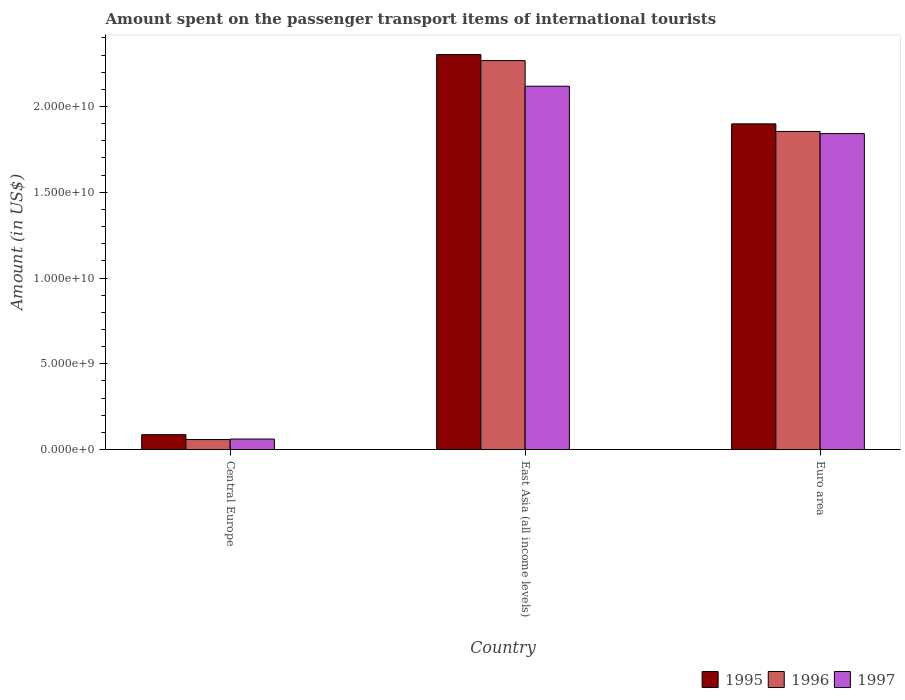How many groups of bars are there?
Ensure brevity in your answer.  3. Are the number of bars per tick equal to the number of legend labels?
Provide a short and direct response. Yes. Are the number of bars on each tick of the X-axis equal?
Keep it short and to the point. Yes. How many bars are there on the 3rd tick from the left?
Provide a short and direct response. 3. What is the label of the 2nd group of bars from the left?
Your response must be concise. East Asia (all income levels). In how many cases, is the number of bars for a given country not equal to the number of legend labels?
Give a very brief answer. 0. What is the amount spent on the passenger transport items of international tourists in 1997 in Euro area?
Provide a short and direct response. 1.84e+1. Across all countries, what is the maximum amount spent on the passenger transport items of international tourists in 1997?
Keep it short and to the point. 2.12e+1. Across all countries, what is the minimum amount spent on the passenger transport items of international tourists in 1997?
Your answer should be compact. 6.10e+08. In which country was the amount spent on the passenger transport items of international tourists in 1997 maximum?
Provide a succinct answer. East Asia (all income levels). In which country was the amount spent on the passenger transport items of international tourists in 1996 minimum?
Ensure brevity in your answer.  Central Europe. What is the total amount spent on the passenger transport items of international tourists in 1997 in the graph?
Your answer should be very brief. 4.02e+1. What is the difference between the amount spent on the passenger transport items of international tourists in 1997 in East Asia (all income levels) and that in Euro area?
Make the answer very short. 2.76e+09. What is the difference between the amount spent on the passenger transport items of international tourists in 1995 in East Asia (all income levels) and the amount spent on the passenger transport items of international tourists in 1996 in Central Europe?
Your response must be concise. 2.24e+1. What is the average amount spent on the passenger transport items of international tourists in 1995 per country?
Your answer should be very brief. 1.43e+1. What is the difference between the amount spent on the passenger transport items of international tourists of/in 1995 and amount spent on the passenger transport items of international tourists of/in 1996 in East Asia (all income levels)?
Keep it short and to the point. 3.50e+08. What is the ratio of the amount spent on the passenger transport items of international tourists in 1996 in Central Europe to that in Euro area?
Offer a very short reply. 0.03. Is the amount spent on the passenger transport items of international tourists in 1995 in Central Europe less than that in Euro area?
Your answer should be very brief. Yes. Is the difference between the amount spent on the passenger transport items of international tourists in 1995 in Central Europe and East Asia (all income levels) greater than the difference between the amount spent on the passenger transport items of international tourists in 1996 in Central Europe and East Asia (all income levels)?
Provide a succinct answer. No. What is the difference between the highest and the second highest amount spent on the passenger transport items of international tourists in 1995?
Provide a succinct answer. -2.22e+1. What is the difference between the highest and the lowest amount spent on the passenger transport items of international tourists in 1996?
Make the answer very short. 2.21e+1. Is the sum of the amount spent on the passenger transport items of international tourists in 1996 in Central Europe and East Asia (all income levels) greater than the maximum amount spent on the passenger transport items of international tourists in 1997 across all countries?
Provide a succinct answer. Yes. How many bars are there?
Your response must be concise. 9. How many countries are there in the graph?
Give a very brief answer. 3. What is the difference between two consecutive major ticks on the Y-axis?
Provide a succinct answer. 5.00e+09. Does the graph contain any zero values?
Give a very brief answer. No. Does the graph contain grids?
Offer a terse response. No. Where does the legend appear in the graph?
Your answer should be compact. Bottom right. What is the title of the graph?
Make the answer very short. Amount spent on the passenger transport items of international tourists. What is the label or title of the X-axis?
Ensure brevity in your answer.  Country. What is the Amount (in US$) in 1995 in Central Europe?
Your answer should be compact. 8.65e+08. What is the Amount (in US$) in 1996 in Central Europe?
Provide a succinct answer. 5.81e+08. What is the Amount (in US$) of 1997 in Central Europe?
Ensure brevity in your answer.  6.10e+08. What is the Amount (in US$) of 1995 in East Asia (all income levels)?
Offer a terse response. 2.30e+1. What is the Amount (in US$) of 1996 in East Asia (all income levels)?
Ensure brevity in your answer.  2.27e+1. What is the Amount (in US$) in 1997 in East Asia (all income levels)?
Ensure brevity in your answer.  2.12e+1. What is the Amount (in US$) in 1995 in Euro area?
Give a very brief answer. 1.90e+1. What is the Amount (in US$) in 1996 in Euro area?
Offer a very short reply. 1.85e+1. What is the Amount (in US$) of 1997 in Euro area?
Offer a very short reply. 1.84e+1. Across all countries, what is the maximum Amount (in US$) in 1995?
Ensure brevity in your answer.  2.30e+1. Across all countries, what is the maximum Amount (in US$) of 1996?
Your response must be concise. 2.27e+1. Across all countries, what is the maximum Amount (in US$) in 1997?
Provide a short and direct response. 2.12e+1. Across all countries, what is the minimum Amount (in US$) in 1995?
Offer a very short reply. 8.65e+08. Across all countries, what is the minimum Amount (in US$) in 1996?
Offer a terse response. 5.81e+08. Across all countries, what is the minimum Amount (in US$) of 1997?
Your answer should be compact. 6.10e+08. What is the total Amount (in US$) of 1995 in the graph?
Offer a very short reply. 4.29e+1. What is the total Amount (in US$) of 1996 in the graph?
Your answer should be compact. 4.18e+1. What is the total Amount (in US$) in 1997 in the graph?
Your response must be concise. 4.02e+1. What is the difference between the Amount (in US$) in 1995 in Central Europe and that in East Asia (all income levels)?
Make the answer very short. -2.22e+1. What is the difference between the Amount (in US$) in 1996 in Central Europe and that in East Asia (all income levels)?
Your answer should be compact. -2.21e+1. What is the difference between the Amount (in US$) of 1997 in Central Europe and that in East Asia (all income levels)?
Make the answer very short. -2.06e+1. What is the difference between the Amount (in US$) in 1995 in Central Europe and that in Euro area?
Your answer should be compact. -1.81e+1. What is the difference between the Amount (in US$) of 1996 in Central Europe and that in Euro area?
Provide a short and direct response. -1.80e+1. What is the difference between the Amount (in US$) in 1997 in Central Europe and that in Euro area?
Provide a short and direct response. -1.78e+1. What is the difference between the Amount (in US$) in 1995 in East Asia (all income levels) and that in Euro area?
Keep it short and to the point. 4.04e+09. What is the difference between the Amount (in US$) in 1996 in East Asia (all income levels) and that in Euro area?
Provide a succinct answer. 4.13e+09. What is the difference between the Amount (in US$) of 1997 in East Asia (all income levels) and that in Euro area?
Keep it short and to the point. 2.76e+09. What is the difference between the Amount (in US$) in 1995 in Central Europe and the Amount (in US$) in 1996 in East Asia (all income levels)?
Your answer should be compact. -2.18e+1. What is the difference between the Amount (in US$) of 1995 in Central Europe and the Amount (in US$) of 1997 in East Asia (all income levels)?
Give a very brief answer. -2.03e+1. What is the difference between the Amount (in US$) of 1996 in Central Europe and the Amount (in US$) of 1997 in East Asia (all income levels)?
Offer a very short reply. -2.06e+1. What is the difference between the Amount (in US$) of 1995 in Central Europe and the Amount (in US$) of 1996 in Euro area?
Your answer should be very brief. -1.77e+1. What is the difference between the Amount (in US$) of 1995 in Central Europe and the Amount (in US$) of 1997 in Euro area?
Give a very brief answer. -1.76e+1. What is the difference between the Amount (in US$) of 1996 in Central Europe and the Amount (in US$) of 1997 in Euro area?
Offer a very short reply. -1.78e+1. What is the difference between the Amount (in US$) in 1995 in East Asia (all income levels) and the Amount (in US$) in 1996 in Euro area?
Make the answer very short. 4.48e+09. What is the difference between the Amount (in US$) in 1995 in East Asia (all income levels) and the Amount (in US$) in 1997 in Euro area?
Ensure brevity in your answer.  4.61e+09. What is the difference between the Amount (in US$) of 1996 in East Asia (all income levels) and the Amount (in US$) of 1997 in Euro area?
Keep it short and to the point. 4.26e+09. What is the average Amount (in US$) of 1995 per country?
Offer a very short reply. 1.43e+1. What is the average Amount (in US$) in 1996 per country?
Ensure brevity in your answer.  1.39e+1. What is the average Amount (in US$) of 1997 per country?
Make the answer very short. 1.34e+1. What is the difference between the Amount (in US$) in 1995 and Amount (in US$) in 1996 in Central Europe?
Offer a terse response. 2.85e+08. What is the difference between the Amount (in US$) in 1995 and Amount (in US$) in 1997 in Central Europe?
Provide a succinct answer. 2.55e+08. What is the difference between the Amount (in US$) in 1996 and Amount (in US$) in 1997 in Central Europe?
Provide a short and direct response. -2.91e+07. What is the difference between the Amount (in US$) in 1995 and Amount (in US$) in 1996 in East Asia (all income levels)?
Provide a short and direct response. 3.50e+08. What is the difference between the Amount (in US$) of 1995 and Amount (in US$) of 1997 in East Asia (all income levels)?
Provide a short and direct response. 1.84e+09. What is the difference between the Amount (in US$) of 1996 and Amount (in US$) of 1997 in East Asia (all income levels)?
Provide a short and direct response. 1.49e+09. What is the difference between the Amount (in US$) of 1995 and Amount (in US$) of 1996 in Euro area?
Give a very brief answer. 4.42e+08. What is the difference between the Amount (in US$) of 1995 and Amount (in US$) of 1997 in Euro area?
Your answer should be compact. 5.69e+08. What is the difference between the Amount (in US$) in 1996 and Amount (in US$) in 1997 in Euro area?
Your answer should be compact. 1.27e+08. What is the ratio of the Amount (in US$) in 1995 in Central Europe to that in East Asia (all income levels)?
Offer a terse response. 0.04. What is the ratio of the Amount (in US$) in 1996 in Central Europe to that in East Asia (all income levels)?
Your answer should be compact. 0.03. What is the ratio of the Amount (in US$) of 1997 in Central Europe to that in East Asia (all income levels)?
Provide a succinct answer. 0.03. What is the ratio of the Amount (in US$) of 1995 in Central Europe to that in Euro area?
Provide a short and direct response. 0.05. What is the ratio of the Amount (in US$) in 1996 in Central Europe to that in Euro area?
Give a very brief answer. 0.03. What is the ratio of the Amount (in US$) in 1997 in Central Europe to that in Euro area?
Provide a succinct answer. 0.03. What is the ratio of the Amount (in US$) in 1995 in East Asia (all income levels) to that in Euro area?
Ensure brevity in your answer.  1.21. What is the ratio of the Amount (in US$) of 1996 in East Asia (all income levels) to that in Euro area?
Ensure brevity in your answer.  1.22. What is the ratio of the Amount (in US$) of 1997 in East Asia (all income levels) to that in Euro area?
Provide a short and direct response. 1.15. What is the difference between the highest and the second highest Amount (in US$) of 1995?
Ensure brevity in your answer.  4.04e+09. What is the difference between the highest and the second highest Amount (in US$) in 1996?
Provide a succinct answer. 4.13e+09. What is the difference between the highest and the second highest Amount (in US$) in 1997?
Keep it short and to the point. 2.76e+09. What is the difference between the highest and the lowest Amount (in US$) of 1995?
Make the answer very short. 2.22e+1. What is the difference between the highest and the lowest Amount (in US$) in 1996?
Ensure brevity in your answer.  2.21e+1. What is the difference between the highest and the lowest Amount (in US$) in 1997?
Keep it short and to the point. 2.06e+1. 